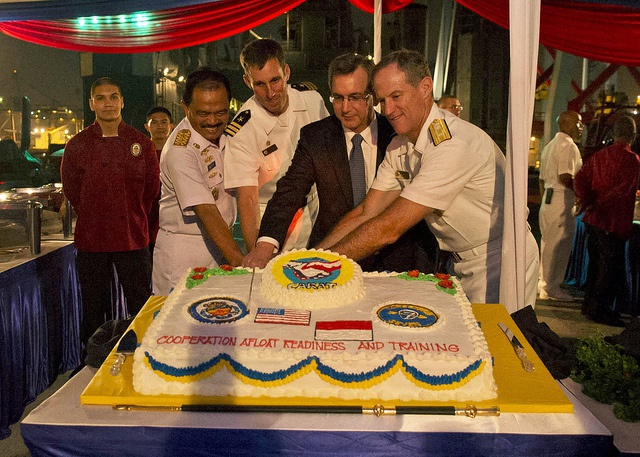Describe the objects in this image and their specific colors. I can see cake in tan tones, people in tan and brown tones, people in tan, black, maroon, and brown tones, people in tan, maroon, gray, and black tones, and people in tan, black, brown, and maroon tones in this image. 